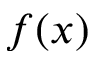<formula> <loc_0><loc_0><loc_500><loc_500>f ( x )</formula> 